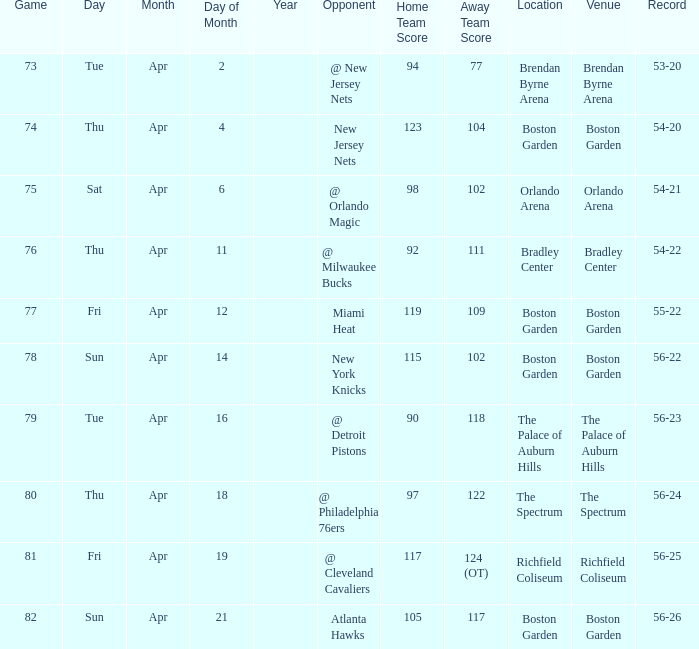Give me the full table as a dictionary. {'header': ['Game', 'Day', 'Month', 'Day of Month', 'Year', 'Opponent', 'Home Team Score', 'Away Team Score', 'Location', 'Venue', 'Record'], 'rows': [['73', 'Tue', 'Apr', '2', '', '@ New Jersey Nets', '94', '77', 'Brendan Byrne Arena', 'Brendan Byrne Arena', '53-20'], ['74', 'Thu', 'Apr', '4', '', 'New Jersey Nets', '123', '104', 'Boston Garden', 'Boston Garden', '54-20'], ['75', 'Sat', 'Apr', '6', '', '@ Orlando Magic', '98', '102', 'Orlando Arena', 'Orlando Arena', '54-21'], ['76', 'Thu', 'Apr', '11', '', '@ Milwaukee Bucks', '92', '111', 'Bradley Center', 'Bradley Center', '54-22'], ['77', 'Fri', 'Apr', '12', '', 'Miami Heat', '119', '109', 'Boston Garden', 'Boston Garden', '55-22'], ['78', 'Sun', 'Apr', '14', '', 'New York Knicks', '115', '102', 'Boston Garden', 'Boston Garden', '56-22'], ['79', 'Tue', 'Apr', '16', '', '@ Detroit Pistons', '90', '118', 'The Palace of Auburn Hills', 'The Palace of Auburn Hills', '56-23'], ['80', 'Thu', 'Apr', '18', '', '@ Philadelphia 76ers', '97', '122', 'The Spectrum', 'The Spectrum', '56-24'], ['81', 'Fri', 'Apr', '19', '', '@ Cleveland Cavaliers', '117', '124 (OT)', 'Richfield Coliseum', 'Richfield Coliseum', '56-25'], ['82', 'Sun', 'Apr', '21', '', 'Atlanta Hawks', '105', '117', 'Boston Garden', 'Boston Garden', '56-26']]} Which Score has a Location of richfield coliseum? 117-124 (OT). 